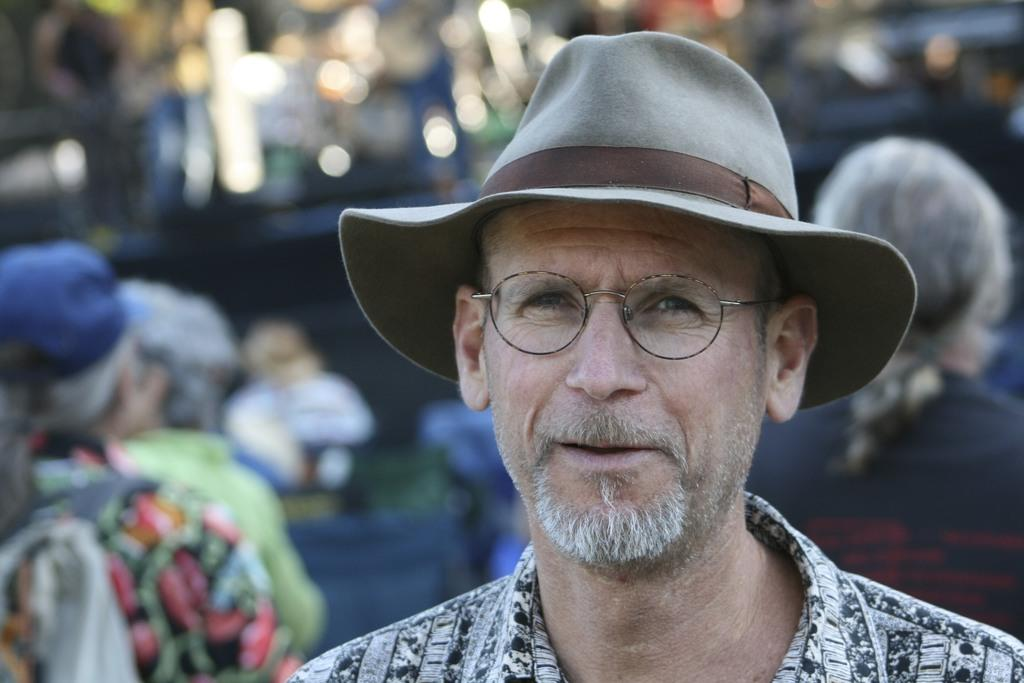What is the main subject of the image? There is a person in the image. Can you describe the person's attire? The person is wearing a hat and spectacles. What can be seen in the background of the image? The background of the image includes people and some objects. How would you describe the quality of the image? The image is blurry. What type of tax is being discussed by the queen in the image? There is no queen present in the image, and therefore no discussion about taxes can be observed. What is the person using to brush their hair in the image? There is no hairbrush or any indication of hair grooming in the image. 